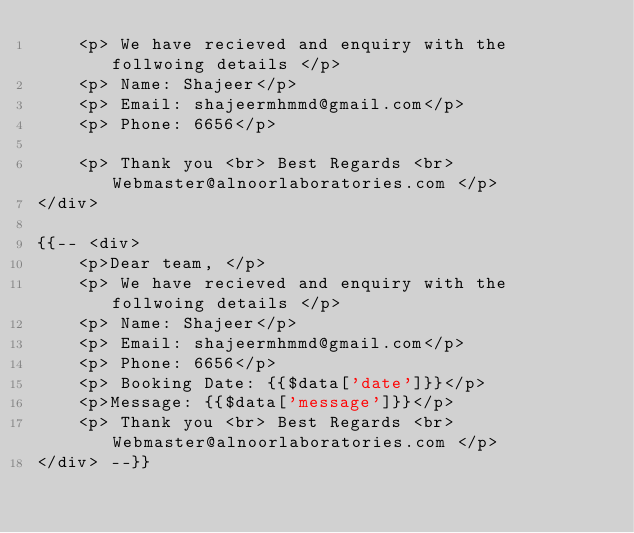<code> <loc_0><loc_0><loc_500><loc_500><_PHP_>    <p> We have recieved and enquiry with the follwoing details </p>
    <p> Name: Shajeer</p>
    <p> Email: shajeermhmmd@gmail.com</p>
    <p> Phone: 6656</p>

    <p> Thank you <br> Best Regards <br> Webmaster@alnoorlaboratories.com </p>
</div>

{{-- <div>
    <p>Dear team, </p>
    <p> We have recieved and enquiry with the follwoing details </p>
    <p> Name: Shajeer</p>
    <p> Email: shajeermhmmd@gmail.com</p>
    <p> Phone: 6656</p>
    <p> Booking Date: {{$data['date']}}</p>
    <p>Message: {{$data['message']}}</p>
    <p> Thank you <br> Best Regards <br> Webmaster@alnoorlaboratories.com </p>
</div> --}}
</code> 